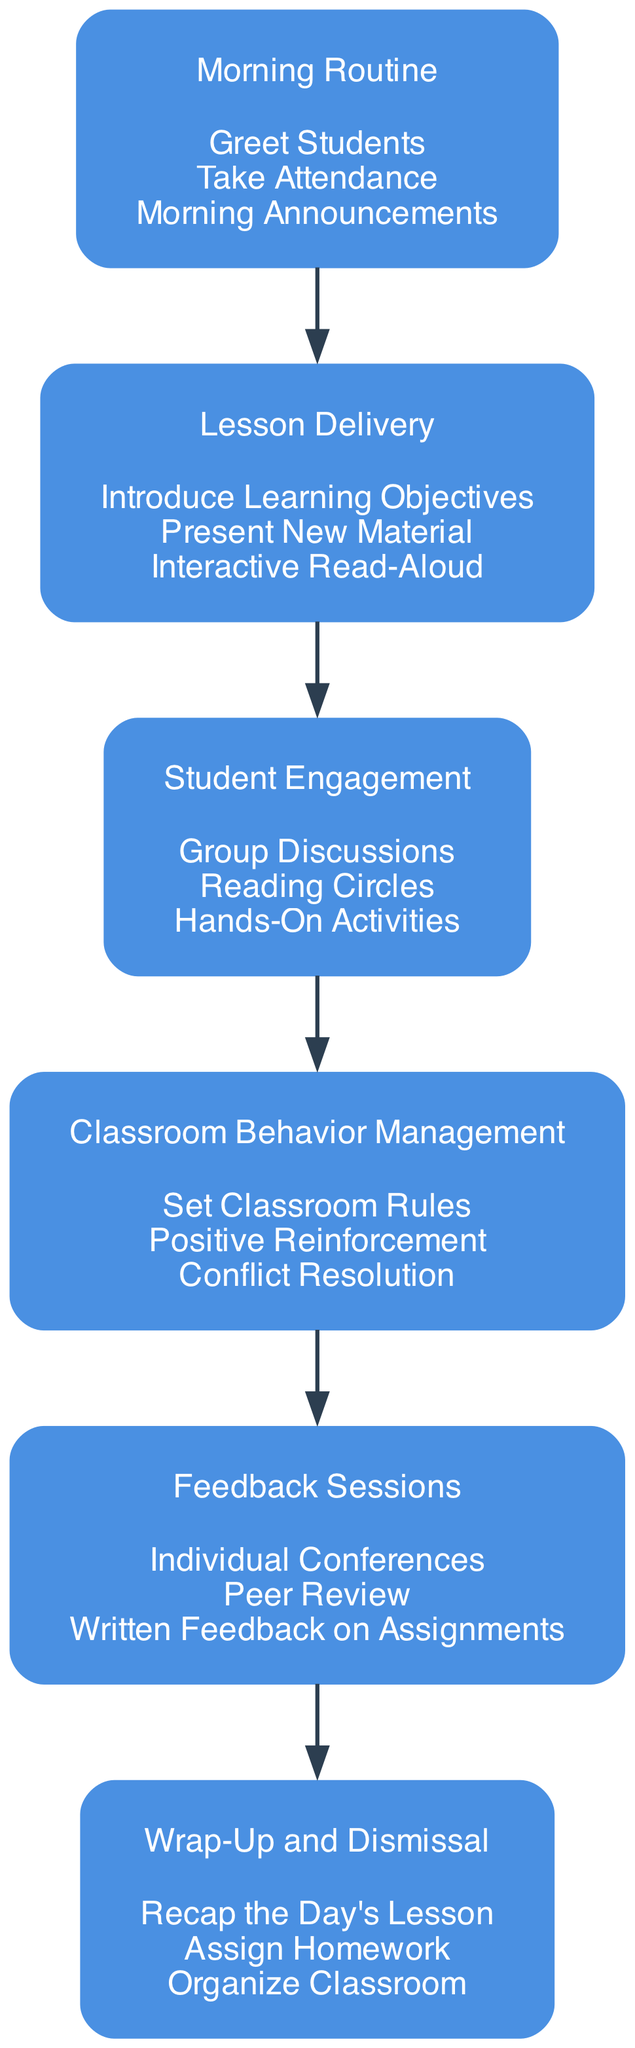What is the first block in the workflow? The first block in the workflow is labeled "Morning Routine." This can be determined by looking at the order of the blocks, which flows from top to bottom.
Answer: Morning Routine How many tasks are included in the "Lesson Delivery" block? The "Lesson Delivery" block contains three tasks. This is shown clearly in the diagram where tasks are listed under the corresponding block name.
Answer: 3 What follows the "Classroom Behavior Management" block? The block that follows "Classroom Behavior Management" is "Feedback Sessions." This can be established by tracing the edges connecting the blocks in the directed graph.
Answer: Feedback Sessions Which block includes "Hands-On Activities"? The block that includes "Hands-On Activities" is "Student Engagement." This task is specifically mentioned under that block in the diagram.
Answer: Student Engagement What is the last block in the workflow? The last block in the workflow is "Wrap-Up and Dismissal." It is the final block listed in the sequence of the diagram.
Answer: Wrap-Up and Dismissal What task is part of the "Morning Routine"? A task that is part of the "Morning Routine" block is "Take Attendance." This task is explicitly mentioned in the list under the associated block in the diagram.
Answer: Take Attendance Describe the relationship between "Lesson Delivery" and "Student Engagement." The relationship is sequential; "Lesson Delivery" leads to "Student Engagement." This is indicated by the edge connecting these two blocks in the diagram.
Answer: Sequential Which task is NOT found in the "Feedback Sessions" block? "Set Classroom Rules" is not found in the "Feedback Sessions" block. This task belongs to the "Classroom Behavior Management" block instead.
Answer: Set Classroom Rules How is student behavior managed according to the diagram? Student behavior is managed through the "Classroom Behavior Management" block, which includes setting classroom rules and providing positive reinforcement. This flow leads from the preceding blocks to address behavior management strategies clearly.
Answer: Classroom Behavior Management 